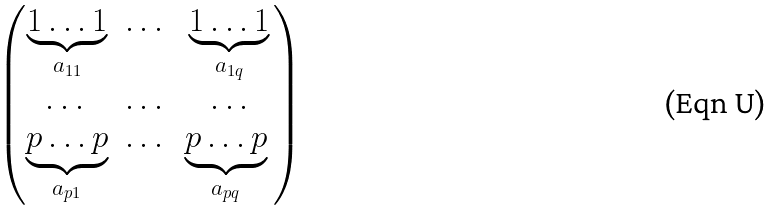<formula> <loc_0><loc_0><loc_500><loc_500>\begin{pmatrix} \underbrace { 1 \dots 1 } _ { a _ { 1 1 } } & \dots & \underbrace { 1 \dots 1 } _ { a _ { 1 q } } \\ \dots & \dots & \dots \\ \underbrace { p \dots p } _ { a _ { p 1 } } & \dots & \underbrace { p \dots p } _ { a _ { p q } } $ $ \end{pmatrix}</formula> 